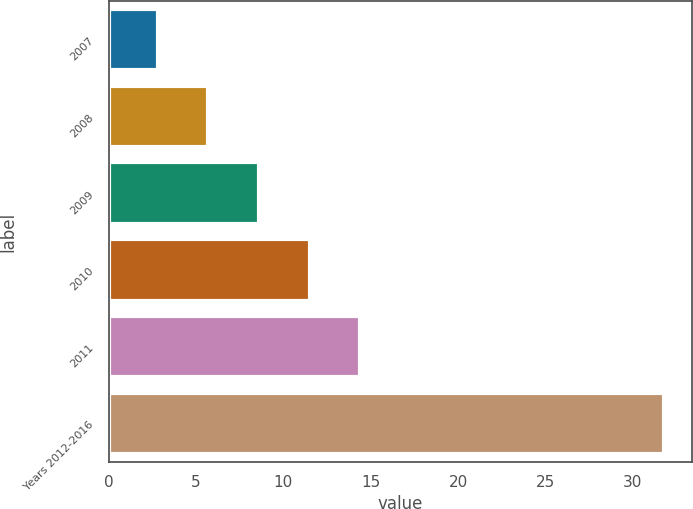Convert chart. <chart><loc_0><loc_0><loc_500><loc_500><bar_chart><fcel>2007<fcel>2008<fcel>2009<fcel>2010<fcel>2011<fcel>Years 2012-2016<nl><fcel>2.8<fcel>5.7<fcel>8.6<fcel>11.5<fcel>14.4<fcel>31.8<nl></chart> 